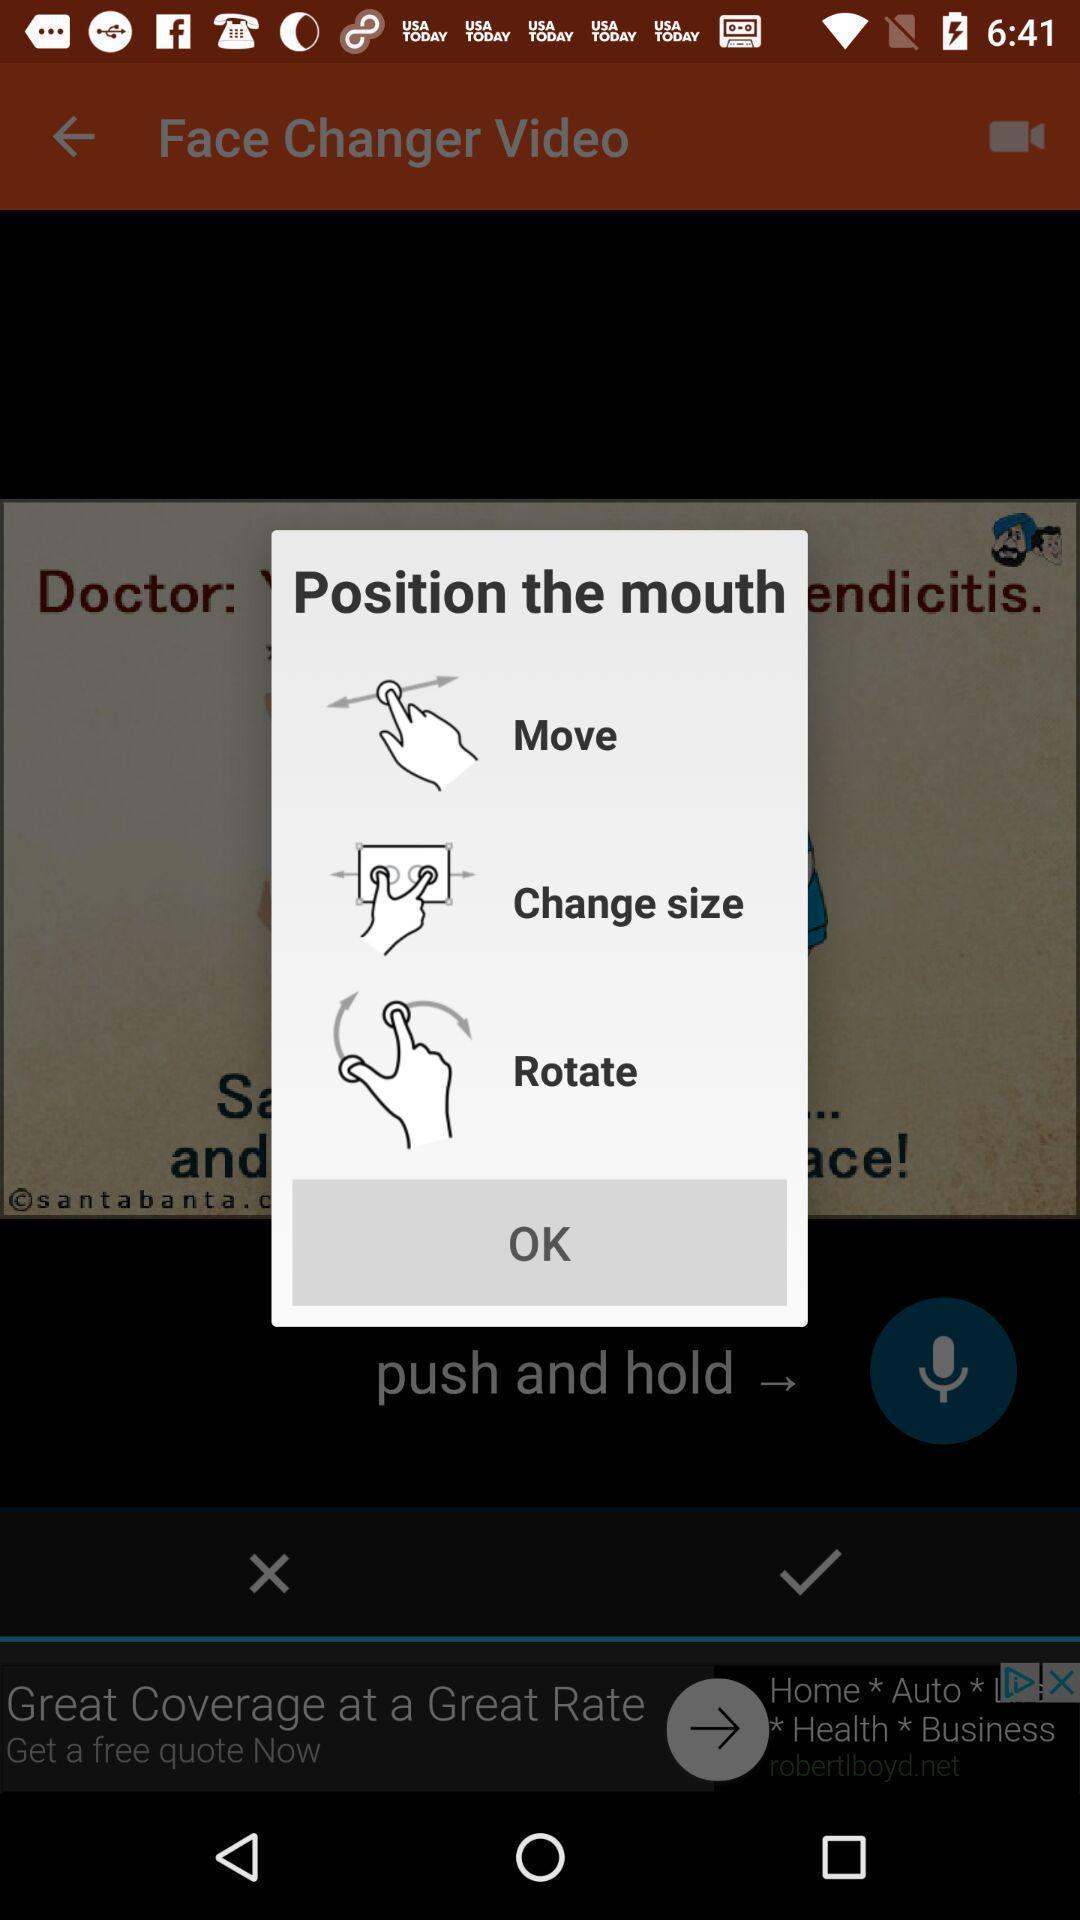Describe the content in this image. Pop-up with options on a editing app. 